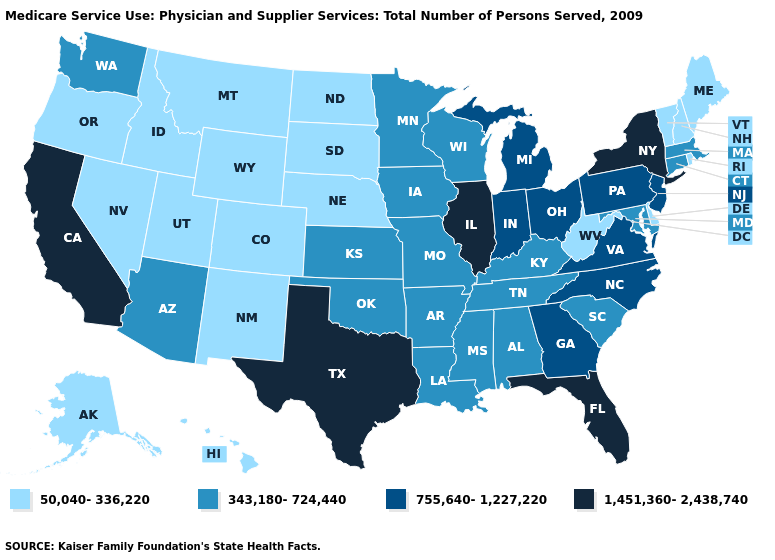Does the map have missing data?
Keep it brief. No. What is the lowest value in the USA?
Short answer required. 50,040-336,220. Name the states that have a value in the range 343,180-724,440?
Give a very brief answer. Alabama, Arizona, Arkansas, Connecticut, Iowa, Kansas, Kentucky, Louisiana, Maryland, Massachusetts, Minnesota, Mississippi, Missouri, Oklahoma, South Carolina, Tennessee, Washington, Wisconsin. What is the value of New Jersey?
Answer briefly. 755,640-1,227,220. Name the states that have a value in the range 343,180-724,440?
Write a very short answer. Alabama, Arizona, Arkansas, Connecticut, Iowa, Kansas, Kentucky, Louisiana, Maryland, Massachusetts, Minnesota, Mississippi, Missouri, Oklahoma, South Carolina, Tennessee, Washington, Wisconsin. Does New Hampshire have a higher value than Massachusetts?
Give a very brief answer. No. Does Oklahoma have a higher value than West Virginia?
Keep it brief. Yes. Does Massachusetts have the lowest value in the Northeast?
Be succinct. No. What is the highest value in the South ?
Concise answer only. 1,451,360-2,438,740. Name the states that have a value in the range 755,640-1,227,220?
Concise answer only. Georgia, Indiana, Michigan, New Jersey, North Carolina, Ohio, Pennsylvania, Virginia. Name the states that have a value in the range 343,180-724,440?
Short answer required. Alabama, Arizona, Arkansas, Connecticut, Iowa, Kansas, Kentucky, Louisiana, Maryland, Massachusetts, Minnesota, Mississippi, Missouri, Oklahoma, South Carolina, Tennessee, Washington, Wisconsin. What is the value of Idaho?
Keep it brief. 50,040-336,220. Name the states that have a value in the range 1,451,360-2,438,740?
Quick response, please. California, Florida, Illinois, New York, Texas. Does Alaska have the highest value in the West?
Quick response, please. No. Name the states that have a value in the range 1,451,360-2,438,740?
Be succinct. California, Florida, Illinois, New York, Texas. 